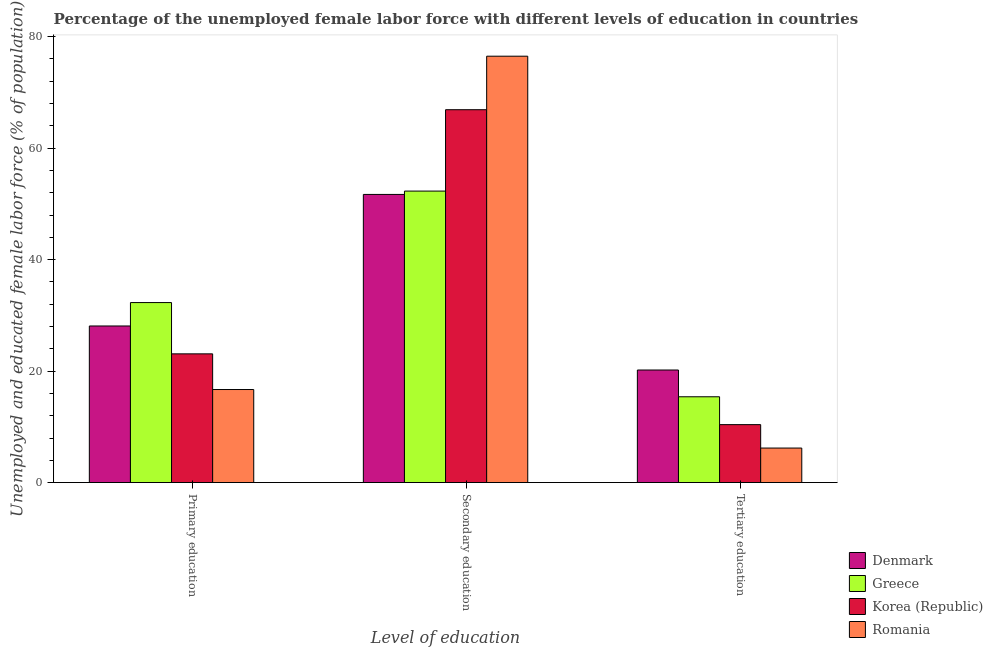Are the number of bars per tick equal to the number of legend labels?
Offer a terse response. Yes. Are the number of bars on each tick of the X-axis equal?
Provide a short and direct response. Yes. How many bars are there on the 1st tick from the right?
Your answer should be very brief. 4. What is the label of the 3rd group of bars from the left?
Your answer should be very brief. Tertiary education. What is the percentage of female labor force who received tertiary education in Greece?
Offer a very short reply. 15.4. Across all countries, what is the maximum percentage of female labor force who received tertiary education?
Give a very brief answer. 20.2. Across all countries, what is the minimum percentage of female labor force who received primary education?
Ensure brevity in your answer.  16.7. In which country was the percentage of female labor force who received tertiary education maximum?
Make the answer very short. Denmark. In which country was the percentage of female labor force who received primary education minimum?
Offer a very short reply. Romania. What is the total percentage of female labor force who received secondary education in the graph?
Offer a terse response. 247.4. What is the difference between the percentage of female labor force who received primary education in Romania and that in Denmark?
Give a very brief answer. -11.4. What is the difference between the percentage of female labor force who received primary education in Romania and the percentage of female labor force who received tertiary education in Greece?
Offer a very short reply. 1.3. What is the average percentage of female labor force who received secondary education per country?
Your response must be concise. 61.85. What is the difference between the percentage of female labor force who received tertiary education and percentage of female labor force who received primary education in Romania?
Give a very brief answer. -10.5. In how many countries, is the percentage of female labor force who received secondary education greater than 12 %?
Make the answer very short. 4. What is the ratio of the percentage of female labor force who received secondary education in Denmark to that in Romania?
Make the answer very short. 0.68. Is the difference between the percentage of female labor force who received secondary education in Korea (Republic) and Denmark greater than the difference between the percentage of female labor force who received primary education in Korea (Republic) and Denmark?
Ensure brevity in your answer.  Yes. What is the difference between the highest and the second highest percentage of female labor force who received primary education?
Make the answer very short. 4.2. What is the difference between the highest and the lowest percentage of female labor force who received secondary education?
Your answer should be compact. 24.8. In how many countries, is the percentage of female labor force who received primary education greater than the average percentage of female labor force who received primary education taken over all countries?
Keep it short and to the point. 2. Is the sum of the percentage of female labor force who received tertiary education in Romania and Greece greater than the maximum percentage of female labor force who received secondary education across all countries?
Your answer should be very brief. No. What does the 4th bar from the left in Primary education represents?
Ensure brevity in your answer.  Romania. What does the 4th bar from the right in Secondary education represents?
Give a very brief answer. Denmark. Is it the case that in every country, the sum of the percentage of female labor force who received primary education and percentage of female labor force who received secondary education is greater than the percentage of female labor force who received tertiary education?
Give a very brief answer. Yes. Are all the bars in the graph horizontal?
Provide a short and direct response. No. Does the graph contain any zero values?
Provide a short and direct response. No. Does the graph contain grids?
Keep it short and to the point. No. What is the title of the graph?
Provide a succinct answer. Percentage of the unemployed female labor force with different levels of education in countries. What is the label or title of the X-axis?
Offer a very short reply. Level of education. What is the label or title of the Y-axis?
Provide a succinct answer. Unemployed and educated female labor force (% of population). What is the Unemployed and educated female labor force (% of population) in Denmark in Primary education?
Your response must be concise. 28.1. What is the Unemployed and educated female labor force (% of population) of Greece in Primary education?
Keep it short and to the point. 32.3. What is the Unemployed and educated female labor force (% of population) in Korea (Republic) in Primary education?
Your answer should be very brief. 23.1. What is the Unemployed and educated female labor force (% of population) of Romania in Primary education?
Provide a short and direct response. 16.7. What is the Unemployed and educated female labor force (% of population) in Denmark in Secondary education?
Make the answer very short. 51.7. What is the Unemployed and educated female labor force (% of population) in Greece in Secondary education?
Ensure brevity in your answer.  52.3. What is the Unemployed and educated female labor force (% of population) of Korea (Republic) in Secondary education?
Keep it short and to the point. 66.9. What is the Unemployed and educated female labor force (% of population) of Romania in Secondary education?
Offer a terse response. 76.5. What is the Unemployed and educated female labor force (% of population) in Denmark in Tertiary education?
Make the answer very short. 20.2. What is the Unemployed and educated female labor force (% of population) in Greece in Tertiary education?
Your answer should be compact. 15.4. What is the Unemployed and educated female labor force (% of population) in Korea (Republic) in Tertiary education?
Your answer should be very brief. 10.4. What is the Unemployed and educated female labor force (% of population) of Romania in Tertiary education?
Your answer should be compact. 6.2. Across all Level of education, what is the maximum Unemployed and educated female labor force (% of population) in Denmark?
Keep it short and to the point. 51.7. Across all Level of education, what is the maximum Unemployed and educated female labor force (% of population) in Greece?
Make the answer very short. 52.3. Across all Level of education, what is the maximum Unemployed and educated female labor force (% of population) of Korea (Republic)?
Ensure brevity in your answer.  66.9. Across all Level of education, what is the maximum Unemployed and educated female labor force (% of population) in Romania?
Offer a very short reply. 76.5. Across all Level of education, what is the minimum Unemployed and educated female labor force (% of population) of Denmark?
Your response must be concise. 20.2. Across all Level of education, what is the minimum Unemployed and educated female labor force (% of population) in Greece?
Offer a very short reply. 15.4. Across all Level of education, what is the minimum Unemployed and educated female labor force (% of population) of Korea (Republic)?
Your answer should be compact. 10.4. Across all Level of education, what is the minimum Unemployed and educated female labor force (% of population) in Romania?
Ensure brevity in your answer.  6.2. What is the total Unemployed and educated female labor force (% of population) of Korea (Republic) in the graph?
Give a very brief answer. 100.4. What is the total Unemployed and educated female labor force (% of population) of Romania in the graph?
Provide a short and direct response. 99.4. What is the difference between the Unemployed and educated female labor force (% of population) of Denmark in Primary education and that in Secondary education?
Give a very brief answer. -23.6. What is the difference between the Unemployed and educated female labor force (% of population) of Korea (Republic) in Primary education and that in Secondary education?
Ensure brevity in your answer.  -43.8. What is the difference between the Unemployed and educated female labor force (% of population) of Romania in Primary education and that in Secondary education?
Make the answer very short. -59.8. What is the difference between the Unemployed and educated female labor force (% of population) of Greece in Primary education and that in Tertiary education?
Your answer should be compact. 16.9. What is the difference between the Unemployed and educated female labor force (% of population) in Romania in Primary education and that in Tertiary education?
Offer a terse response. 10.5. What is the difference between the Unemployed and educated female labor force (% of population) of Denmark in Secondary education and that in Tertiary education?
Keep it short and to the point. 31.5. What is the difference between the Unemployed and educated female labor force (% of population) in Greece in Secondary education and that in Tertiary education?
Your answer should be compact. 36.9. What is the difference between the Unemployed and educated female labor force (% of population) in Korea (Republic) in Secondary education and that in Tertiary education?
Give a very brief answer. 56.5. What is the difference between the Unemployed and educated female labor force (% of population) of Romania in Secondary education and that in Tertiary education?
Ensure brevity in your answer.  70.3. What is the difference between the Unemployed and educated female labor force (% of population) of Denmark in Primary education and the Unemployed and educated female labor force (% of population) of Greece in Secondary education?
Provide a succinct answer. -24.2. What is the difference between the Unemployed and educated female labor force (% of population) of Denmark in Primary education and the Unemployed and educated female labor force (% of population) of Korea (Republic) in Secondary education?
Provide a short and direct response. -38.8. What is the difference between the Unemployed and educated female labor force (% of population) of Denmark in Primary education and the Unemployed and educated female labor force (% of population) of Romania in Secondary education?
Give a very brief answer. -48.4. What is the difference between the Unemployed and educated female labor force (% of population) of Greece in Primary education and the Unemployed and educated female labor force (% of population) of Korea (Republic) in Secondary education?
Your answer should be compact. -34.6. What is the difference between the Unemployed and educated female labor force (% of population) of Greece in Primary education and the Unemployed and educated female labor force (% of population) of Romania in Secondary education?
Offer a very short reply. -44.2. What is the difference between the Unemployed and educated female labor force (% of population) of Korea (Republic) in Primary education and the Unemployed and educated female labor force (% of population) of Romania in Secondary education?
Your answer should be very brief. -53.4. What is the difference between the Unemployed and educated female labor force (% of population) in Denmark in Primary education and the Unemployed and educated female labor force (% of population) in Greece in Tertiary education?
Offer a terse response. 12.7. What is the difference between the Unemployed and educated female labor force (% of population) in Denmark in Primary education and the Unemployed and educated female labor force (% of population) in Romania in Tertiary education?
Offer a very short reply. 21.9. What is the difference between the Unemployed and educated female labor force (% of population) of Greece in Primary education and the Unemployed and educated female labor force (% of population) of Korea (Republic) in Tertiary education?
Keep it short and to the point. 21.9. What is the difference between the Unemployed and educated female labor force (% of population) in Greece in Primary education and the Unemployed and educated female labor force (% of population) in Romania in Tertiary education?
Your response must be concise. 26.1. What is the difference between the Unemployed and educated female labor force (% of population) in Denmark in Secondary education and the Unemployed and educated female labor force (% of population) in Greece in Tertiary education?
Provide a succinct answer. 36.3. What is the difference between the Unemployed and educated female labor force (% of population) of Denmark in Secondary education and the Unemployed and educated female labor force (% of population) of Korea (Republic) in Tertiary education?
Provide a short and direct response. 41.3. What is the difference between the Unemployed and educated female labor force (% of population) of Denmark in Secondary education and the Unemployed and educated female labor force (% of population) of Romania in Tertiary education?
Give a very brief answer. 45.5. What is the difference between the Unemployed and educated female labor force (% of population) of Greece in Secondary education and the Unemployed and educated female labor force (% of population) of Korea (Republic) in Tertiary education?
Give a very brief answer. 41.9. What is the difference between the Unemployed and educated female labor force (% of population) in Greece in Secondary education and the Unemployed and educated female labor force (% of population) in Romania in Tertiary education?
Provide a succinct answer. 46.1. What is the difference between the Unemployed and educated female labor force (% of population) of Korea (Republic) in Secondary education and the Unemployed and educated female labor force (% of population) of Romania in Tertiary education?
Provide a short and direct response. 60.7. What is the average Unemployed and educated female labor force (% of population) of Denmark per Level of education?
Provide a succinct answer. 33.33. What is the average Unemployed and educated female labor force (% of population) in Greece per Level of education?
Give a very brief answer. 33.33. What is the average Unemployed and educated female labor force (% of population) in Korea (Republic) per Level of education?
Your response must be concise. 33.47. What is the average Unemployed and educated female labor force (% of population) in Romania per Level of education?
Offer a terse response. 33.13. What is the difference between the Unemployed and educated female labor force (% of population) of Denmark and Unemployed and educated female labor force (% of population) of Korea (Republic) in Primary education?
Offer a terse response. 5. What is the difference between the Unemployed and educated female labor force (% of population) of Greece and Unemployed and educated female labor force (% of population) of Romania in Primary education?
Offer a terse response. 15.6. What is the difference between the Unemployed and educated female labor force (% of population) of Korea (Republic) and Unemployed and educated female labor force (% of population) of Romania in Primary education?
Keep it short and to the point. 6.4. What is the difference between the Unemployed and educated female labor force (% of population) of Denmark and Unemployed and educated female labor force (% of population) of Greece in Secondary education?
Give a very brief answer. -0.6. What is the difference between the Unemployed and educated female labor force (% of population) of Denmark and Unemployed and educated female labor force (% of population) of Korea (Republic) in Secondary education?
Keep it short and to the point. -15.2. What is the difference between the Unemployed and educated female labor force (% of population) in Denmark and Unemployed and educated female labor force (% of population) in Romania in Secondary education?
Ensure brevity in your answer.  -24.8. What is the difference between the Unemployed and educated female labor force (% of population) of Greece and Unemployed and educated female labor force (% of population) of Korea (Republic) in Secondary education?
Provide a succinct answer. -14.6. What is the difference between the Unemployed and educated female labor force (% of population) in Greece and Unemployed and educated female labor force (% of population) in Romania in Secondary education?
Your answer should be compact. -24.2. What is the difference between the Unemployed and educated female labor force (% of population) of Denmark and Unemployed and educated female labor force (% of population) of Greece in Tertiary education?
Provide a short and direct response. 4.8. What is the difference between the Unemployed and educated female labor force (% of population) in Greece and Unemployed and educated female labor force (% of population) in Korea (Republic) in Tertiary education?
Your response must be concise. 5. What is the ratio of the Unemployed and educated female labor force (% of population) in Denmark in Primary education to that in Secondary education?
Provide a succinct answer. 0.54. What is the ratio of the Unemployed and educated female labor force (% of population) of Greece in Primary education to that in Secondary education?
Your response must be concise. 0.62. What is the ratio of the Unemployed and educated female labor force (% of population) in Korea (Republic) in Primary education to that in Secondary education?
Your answer should be very brief. 0.35. What is the ratio of the Unemployed and educated female labor force (% of population) of Romania in Primary education to that in Secondary education?
Provide a succinct answer. 0.22. What is the ratio of the Unemployed and educated female labor force (% of population) in Denmark in Primary education to that in Tertiary education?
Provide a short and direct response. 1.39. What is the ratio of the Unemployed and educated female labor force (% of population) in Greece in Primary education to that in Tertiary education?
Provide a short and direct response. 2.1. What is the ratio of the Unemployed and educated female labor force (% of population) of Korea (Republic) in Primary education to that in Tertiary education?
Your answer should be compact. 2.22. What is the ratio of the Unemployed and educated female labor force (% of population) in Romania in Primary education to that in Tertiary education?
Provide a short and direct response. 2.69. What is the ratio of the Unemployed and educated female labor force (% of population) of Denmark in Secondary education to that in Tertiary education?
Your response must be concise. 2.56. What is the ratio of the Unemployed and educated female labor force (% of population) in Greece in Secondary education to that in Tertiary education?
Offer a terse response. 3.4. What is the ratio of the Unemployed and educated female labor force (% of population) in Korea (Republic) in Secondary education to that in Tertiary education?
Make the answer very short. 6.43. What is the ratio of the Unemployed and educated female labor force (% of population) in Romania in Secondary education to that in Tertiary education?
Provide a succinct answer. 12.34. What is the difference between the highest and the second highest Unemployed and educated female labor force (% of population) in Denmark?
Your answer should be very brief. 23.6. What is the difference between the highest and the second highest Unemployed and educated female labor force (% of population) in Greece?
Keep it short and to the point. 20. What is the difference between the highest and the second highest Unemployed and educated female labor force (% of population) of Korea (Republic)?
Offer a terse response. 43.8. What is the difference between the highest and the second highest Unemployed and educated female labor force (% of population) of Romania?
Provide a short and direct response. 59.8. What is the difference between the highest and the lowest Unemployed and educated female labor force (% of population) in Denmark?
Ensure brevity in your answer.  31.5. What is the difference between the highest and the lowest Unemployed and educated female labor force (% of population) in Greece?
Offer a terse response. 36.9. What is the difference between the highest and the lowest Unemployed and educated female labor force (% of population) in Korea (Republic)?
Your response must be concise. 56.5. What is the difference between the highest and the lowest Unemployed and educated female labor force (% of population) of Romania?
Your response must be concise. 70.3. 